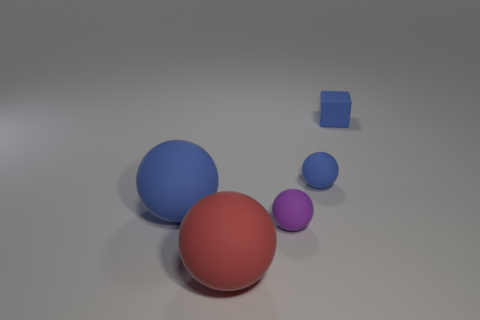What number of red matte things have the same size as the block?
Provide a short and direct response. 0. What number of tiny objects are either matte cubes or brown rubber cylinders?
Provide a short and direct response. 1. What number of tiny purple matte objects are there?
Your response must be concise. 1. Are there an equal number of tiny rubber blocks that are in front of the big red object and tiny blue things that are on the right side of the tiny blue rubber block?
Your answer should be very brief. Yes. There is a tiny purple sphere; are there any blue rubber things right of it?
Your answer should be very brief. Yes. What is the color of the big matte ball in front of the tiny purple rubber object?
Give a very brief answer. Red. There is a tiny ball in front of the small blue rubber object to the left of the tiny blue rubber cube; what is it made of?
Give a very brief answer. Rubber. Are there fewer blue matte objects that are right of the big red matte thing than spheres left of the small blue matte sphere?
Your answer should be compact. Yes. What number of red objects are either tiny rubber objects or balls?
Keep it short and to the point. 1. Are there an equal number of blue matte blocks in front of the small purple sphere and large gray rubber things?
Make the answer very short. Yes. 